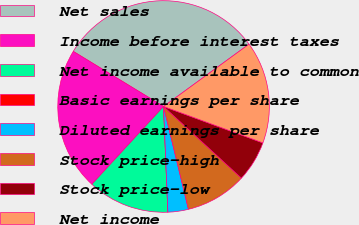Convert chart. <chart><loc_0><loc_0><loc_500><loc_500><pie_chart><fcel>Net sales<fcel>Income before interest taxes<fcel>Net income available to common<fcel>Basic earnings per share<fcel>Diluted earnings per share<fcel>Stock price-high<fcel>Stock price-low<fcel>Net income<nl><fcel>31.25%<fcel>21.87%<fcel>12.5%<fcel>0.0%<fcel>3.13%<fcel>9.38%<fcel>6.25%<fcel>15.62%<nl></chart> 